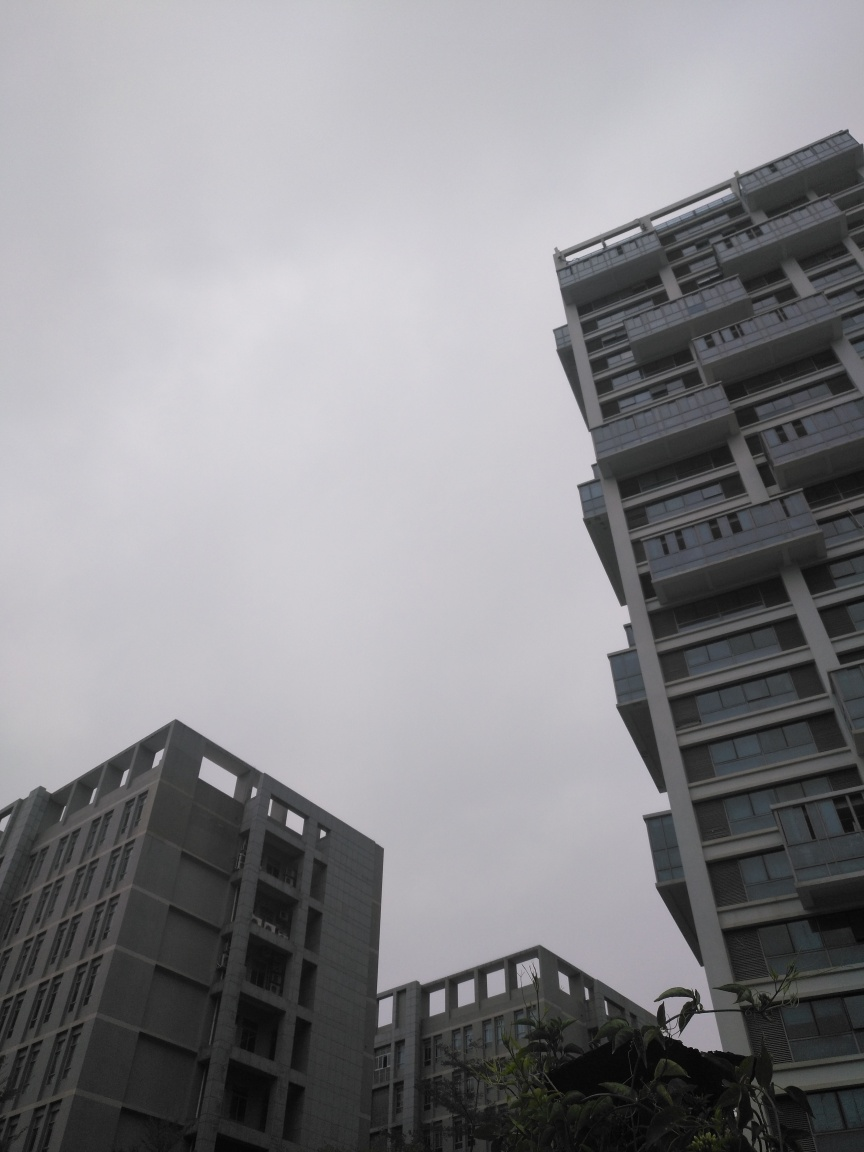How might weather conditions affect the perception of this image? The overcast sky in this image casts a uniform soft light, which reduces shadows and may diminish the sense of depth and texture in the buildings. While this can lead to a subdued appearance, it also brings out the true colors of the structures without the harsh glare often caused by direct sunlight. This kind of lighting can make architectural photos feel more solemn and moody. 